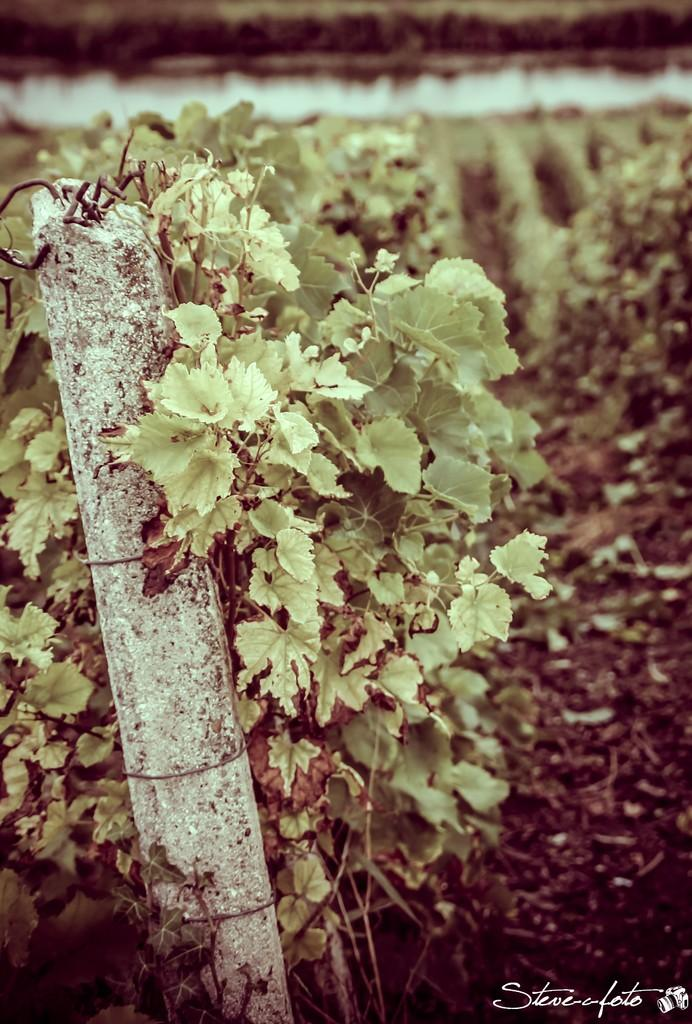What type of living organisms can be seen in the image? Plants can be seen in the image. What is attached to the pole in the image? There are some objects attached to the pole in the image. Where is the text located in the image? The text is visible in the bottom right corner of the image. What type of glass is being used by the porter in the image? There is no porter or glass present in the image. 